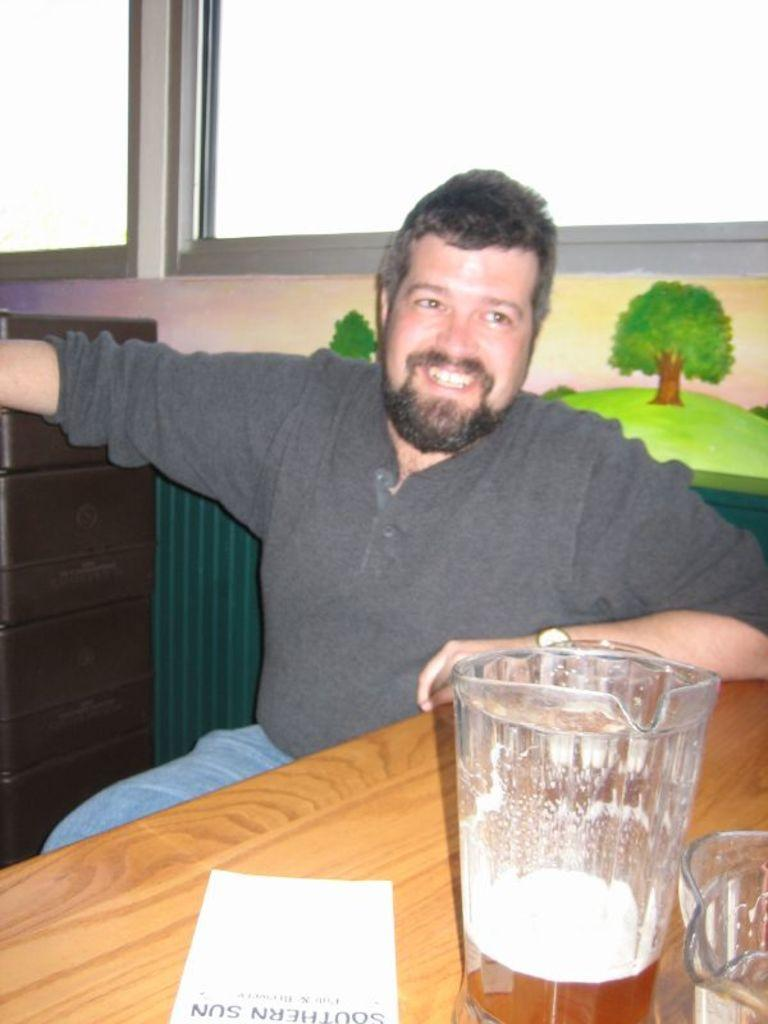What is the man in the image doing? The man is sitting in the image. Where is the man located in relation to the table? The man is in front of a table. What objects are on the table? There is a jug and a paper on the table. What can be seen in the background of the image? There is a window in the background of the image. What type of force is being applied to the jug in the image? There is no indication of any force being applied to the jug in the image; it is simply sitting on the table. 